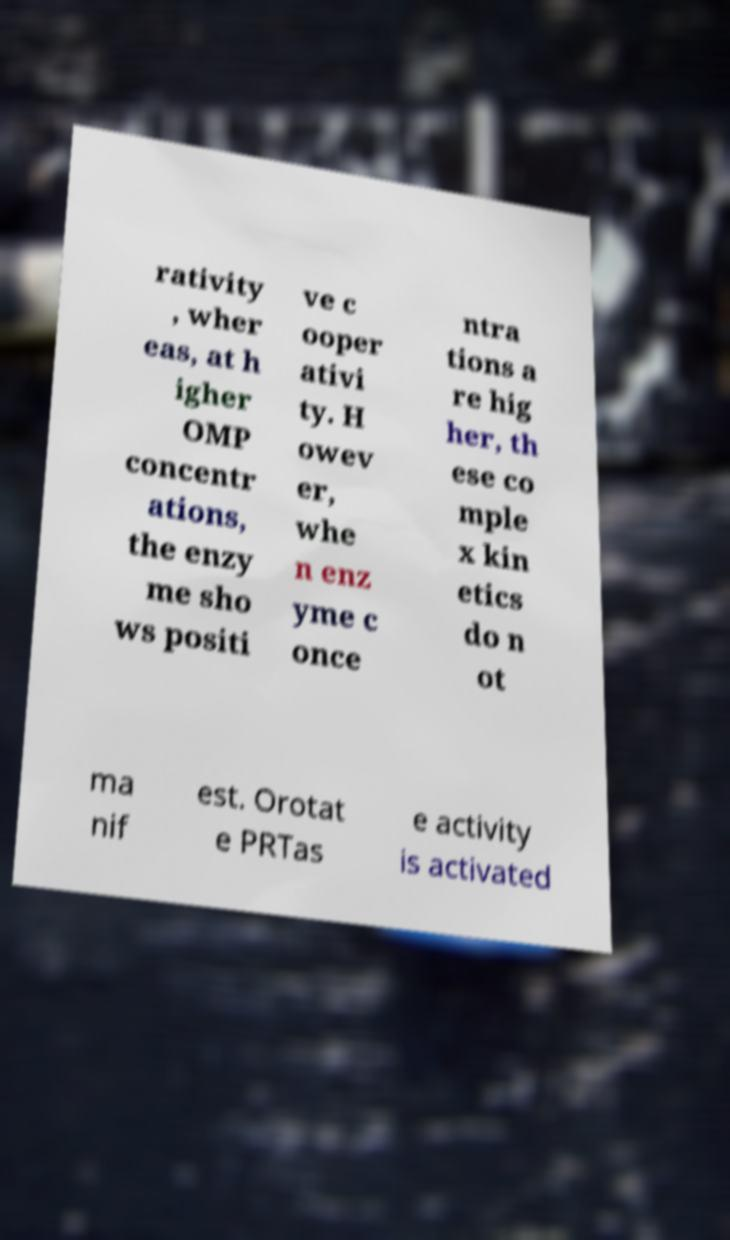I need the written content from this picture converted into text. Can you do that? rativity , wher eas, at h igher OMP concentr ations, the enzy me sho ws positi ve c ooper ativi ty. H owev er, whe n enz yme c once ntra tions a re hig her, th ese co mple x kin etics do n ot ma nif est. Orotat e PRTas e activity is activated 